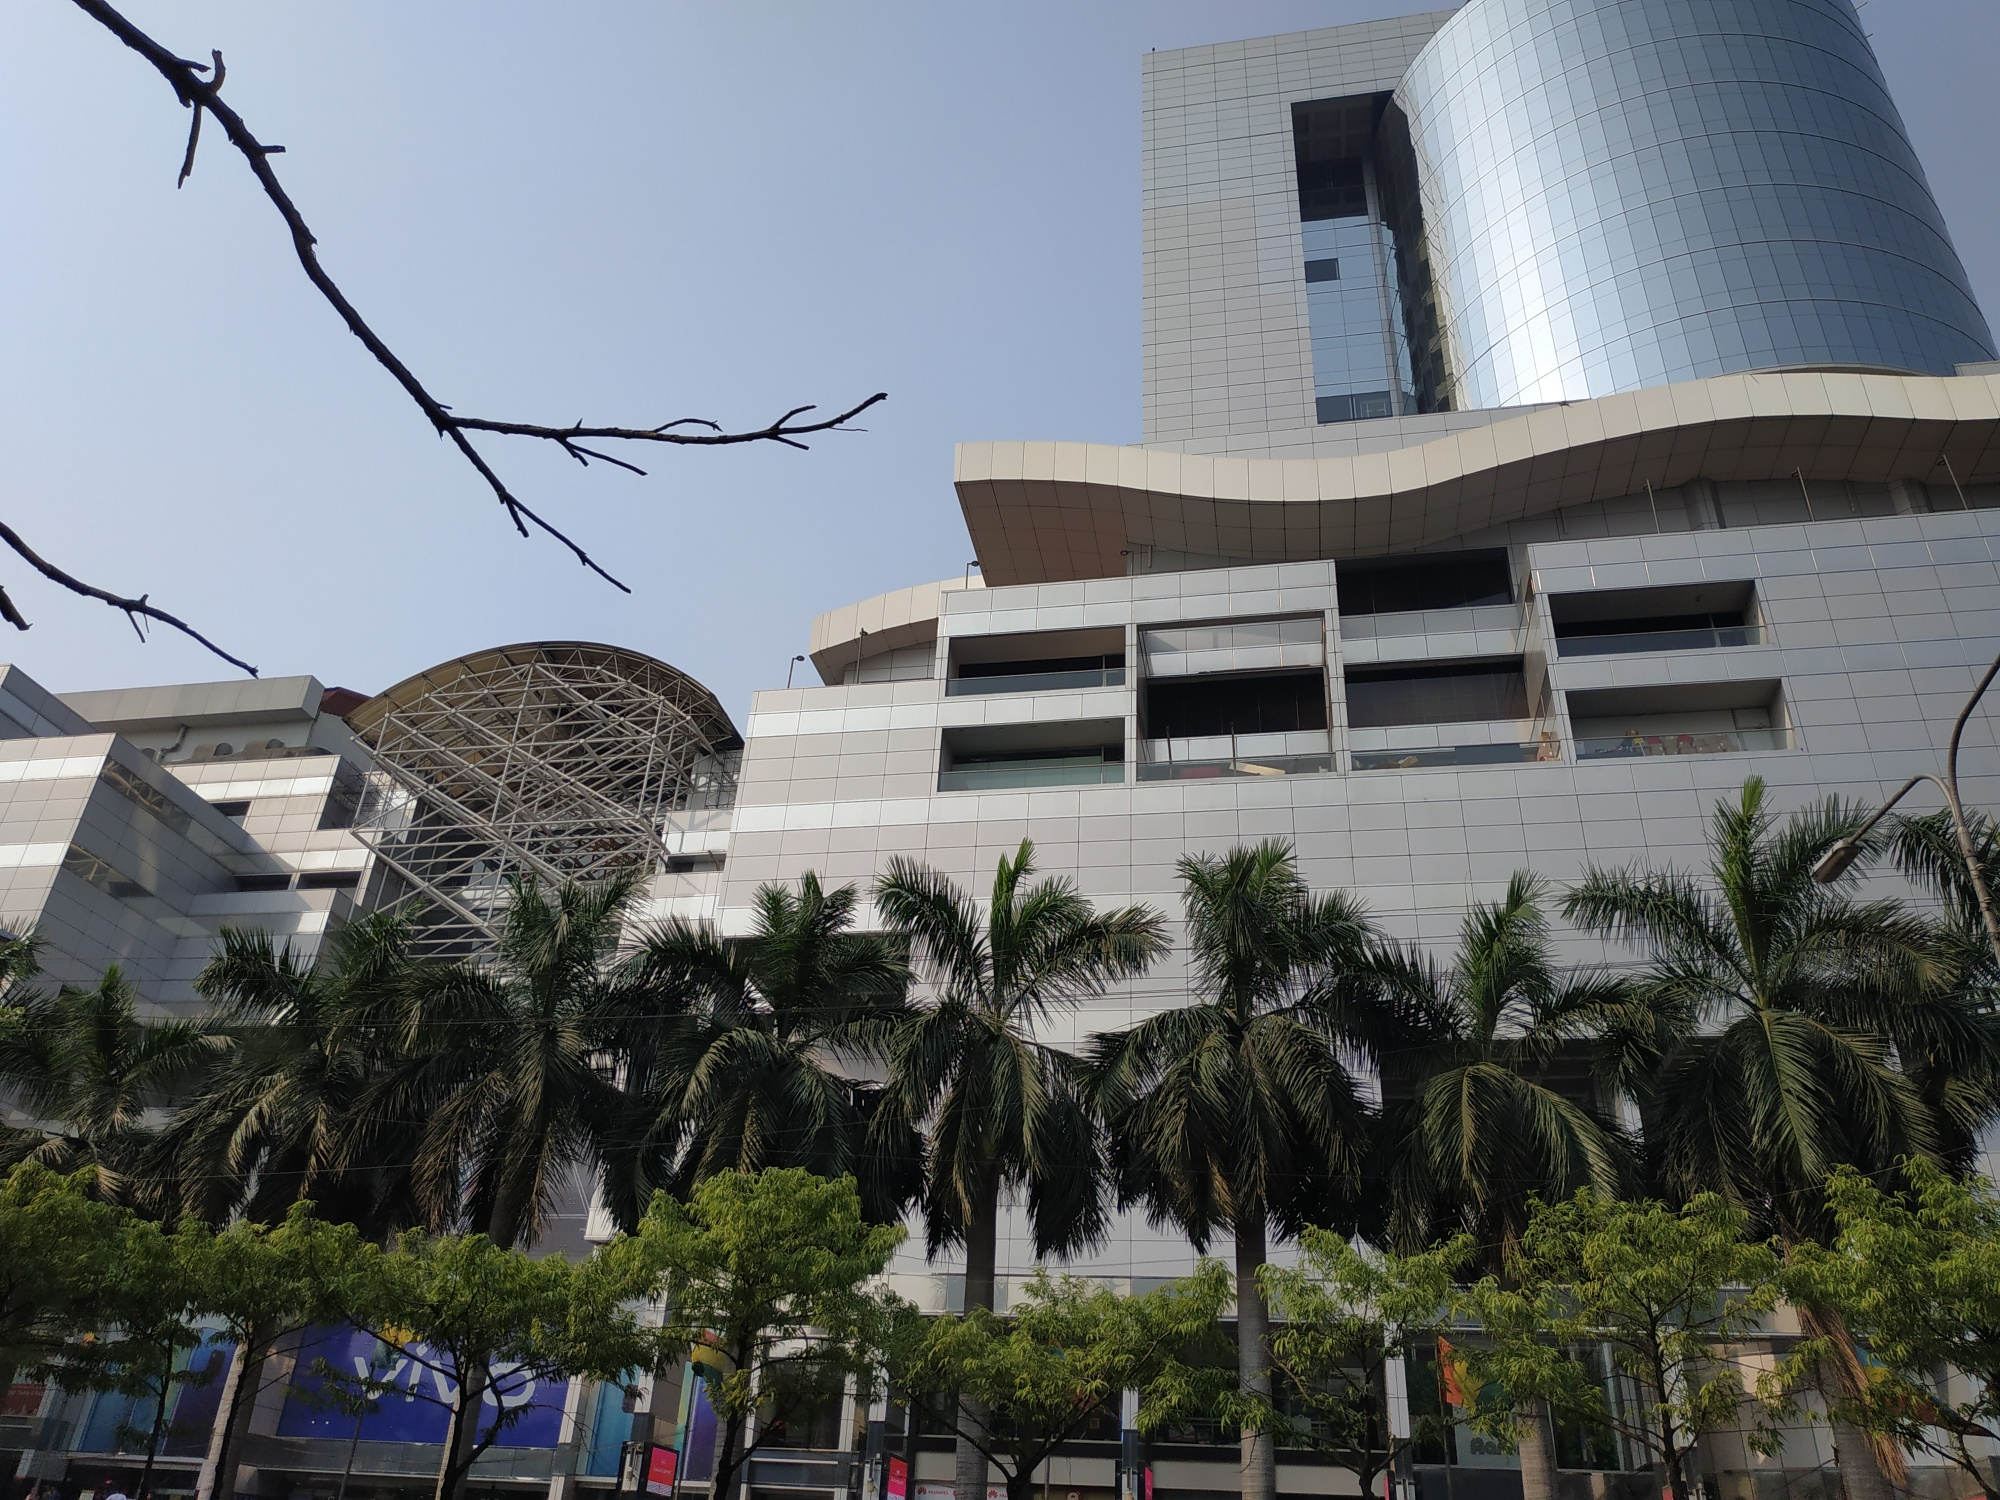If this building was a character in a science fiction novel, what role would it play? In a science fiction novel, this building could be envisioned as the central hub of a futuristic city, a towering beacon of technological advancement and architectural innovation. It serves as the headquarters for an elite team of scientists and thinkers who are at the forefront of pushing the boundaries of human understanding. The building itself, equipped with an AI system, is almost sentient, assisting inhabitants with daily tasks and safeguarding the city's advanced systems. The metal dome acts as a communication array, enabling instant communication across the galaxy, while the reflective glass facade serves as a cloaking mechanism against potential extraterrestrial threats. This structure is not just a place of work but a symbol of humanity’s resilience and ingenuity in a universe filled with endless possibilities. 